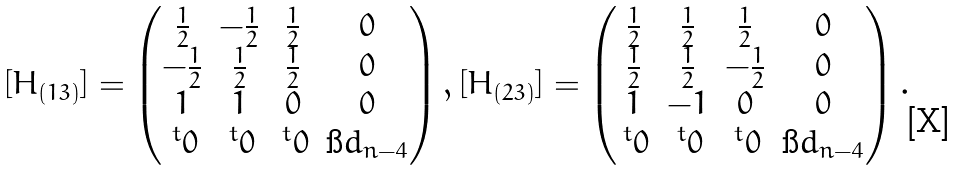Convert formula to latex. <formula><loc_0><loc_0><loc_500><loc_500>\begin{array} { c c } [ H _ { ( 1 3 ) } ] = \begin{pmatrix} \frac { 1 } { 2 } & - \frac { 1 } { 2 } & \frac { 1 } { 2 } & 0 \\ - \frac { 1 } { 2 } & \frac { 1 } { 2 } & \frac { 1 } { 2 } & 0 \\ 1 & 1 & 0 & 0 \\ \, ^ { t } 0 & \, ^ { t } 0 & \, ^ { t } 0 & \i d _ { n - 4 } \end{pmatrix} , [ H _ { ( 2 3 ) } ] = \begin{pmatrix} \frac { 1 } { 2 } & \frac { 1 } { 2 } & \frac { 1 } { 2 } & 0 \\ \frac { 1 } { 2 } & \frac { 1 } { 2 } & - \frac { 1 } { 2 } & 0 \\ 1 & - 1 & 0 & 0 \\ \, ^ { t } 0 & \, ^ { t } 0 & \, ^ { t } 0 & \i d _ { n - 4 } \end{pmatrix} . \end{array}</formula> 